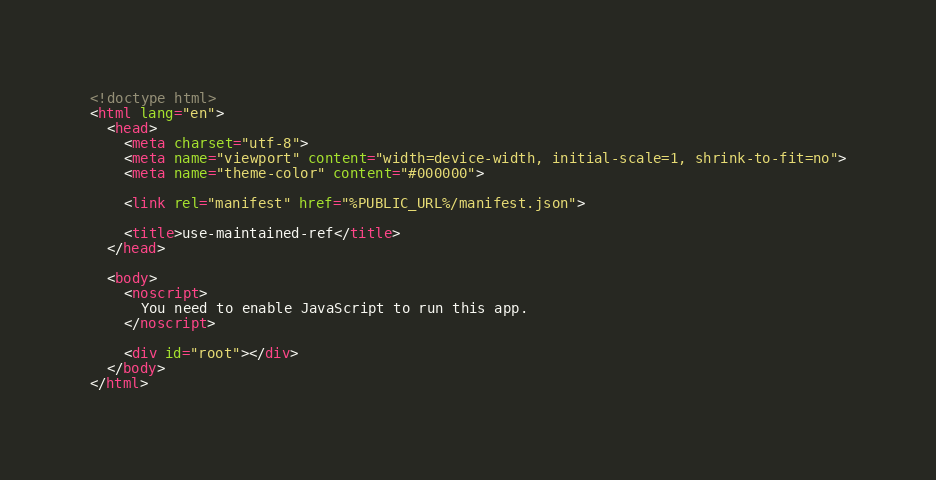<code> <loc_0><loc_0><loc_500><loc_500><_HTML_><!doctype html>
<html lang="en">
  <head>
    <meta charset="utf-8">
    <meta name="viewport" content="width=device-width, initial-scale=1, shrink-to-fit=no">
    <meta name="theme-color" content="#000000">

    <link rel="manifest" href="%PUBLIC_URL%/manifest.json">

    <title>use-maintained-ref</title>
  </head>

  <body>
    <noscript>
      You need to enable JavaScript to run this app.
    </noscript>

    <div id="root"></div>
  </body>
</html>
</code> 